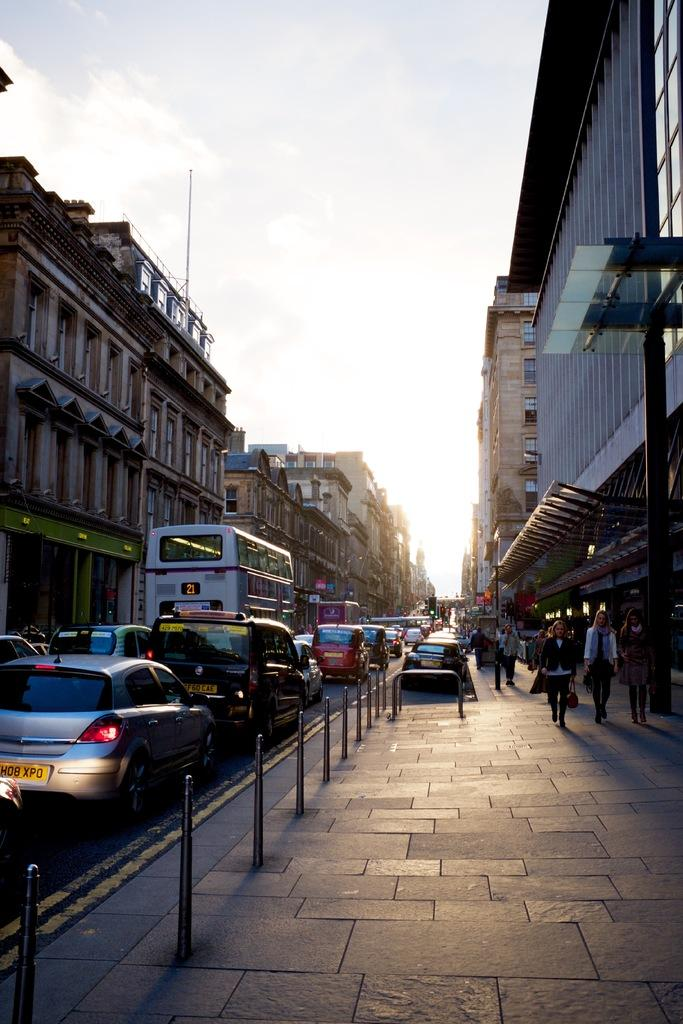<image>
Present a compact description of the photo's key features. A busy street with the number 21 bus stuck in traffic. 